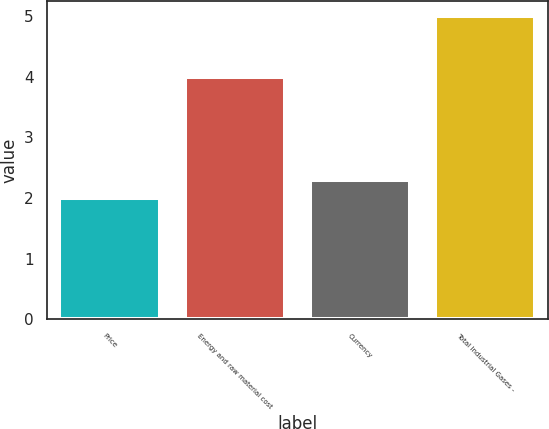<chart> <loc_0><loc_0><loc_500><loc_500><bar_chart><fcel>Price<fcel>Energy and raw material cost<fcel>Currency<fcel>Total Industrial Gases -<nl><fcel>2<fcel>4<fcel>2.3<fcel>5<nl></chart> 